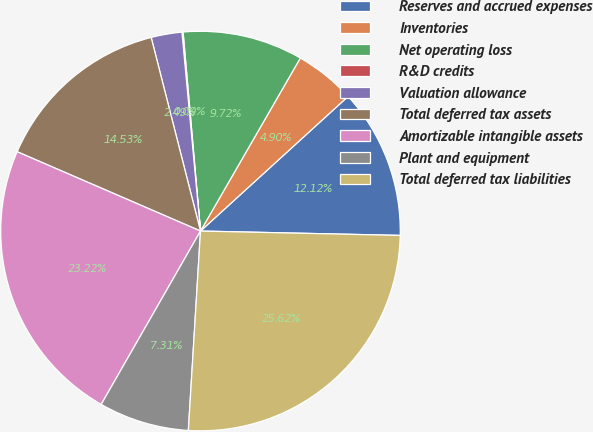Convert chart to OTSL. <chart><loc_0><loc_0><loc_500><loc_500><pie_chart><fcel>Reserves and accrued expenses<fcel>Inventories<fcel>Net operating loss<fcel>R&D credits<fcel>Valuation allowance<fcel>Total deferred tax assets<fcel>Amortizable intangible assets<fcel>Plant and equipment<fcel>Total deferred tax liabilities<nl><fcel>12.12%<fcel>4.9%<fcel>9.72%<fcel>0.09%<fcel>2.49%<fcel>14.53%<fcel>23.22%<fcel>7.31%<fcel>25.62%<nl></chart> 